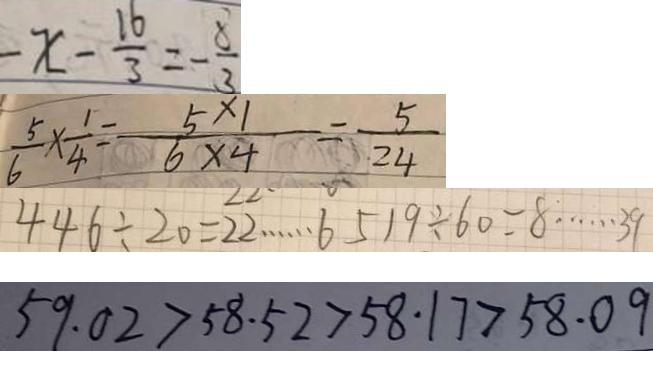<formula> <loc_0><loc_0><loc_500><loc_500>- x - \frac { 1 6 } { 3 } = - \frac { 8 } { 3 } 
 \frac { 5 } { 6 } \times \frac { 1 } { 4 } = \frac { 5 \times 1 } { 6 \times 4 } = \frac { 5 } { 2 4 } 
 4 4 6 \div 2 0 = 2 2 \cdots 6 5 1 9 \div 6 0 = 8 \cdots 3 9 
 5 9 . 0 2 > 5 8 . 5 2 > 5 8 . 1 7 > 5 8 . 0 9</formula> 